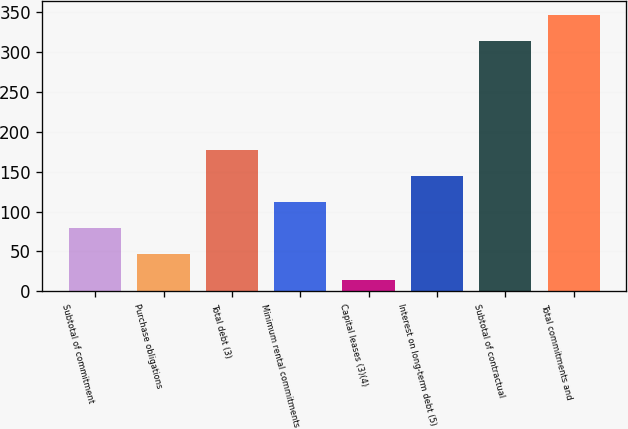Convert chart. <chart><loc_0><loc_0><loc_500><loc_500><bar_chart><fcel>Subtotal of commitment<fcel>Purchase obligations<fcel>Total debt (3)<fcel>Minimum rental commitments<fcel>Capital leases (3)(4)<fcel>Interest on long-term debt (5)<fcel>Subtotal of contractual<fcel>Total commitments and<nl><fcel>79.4<fcel>46.7<fcel>177.5<fcel>112.1<fcel>14<fcel>144.8<fcel>313<fcel>345.7<nl></chart> 